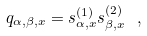<formula> <loc_0><loc_0><loc_500><loc_500>q _ { \alpha , \beta , x } = s ^ { ( 1 ) } _ { \alpha , x } s ^ { ( 2 ) } _ { \beta , x } \ ,</formula> 